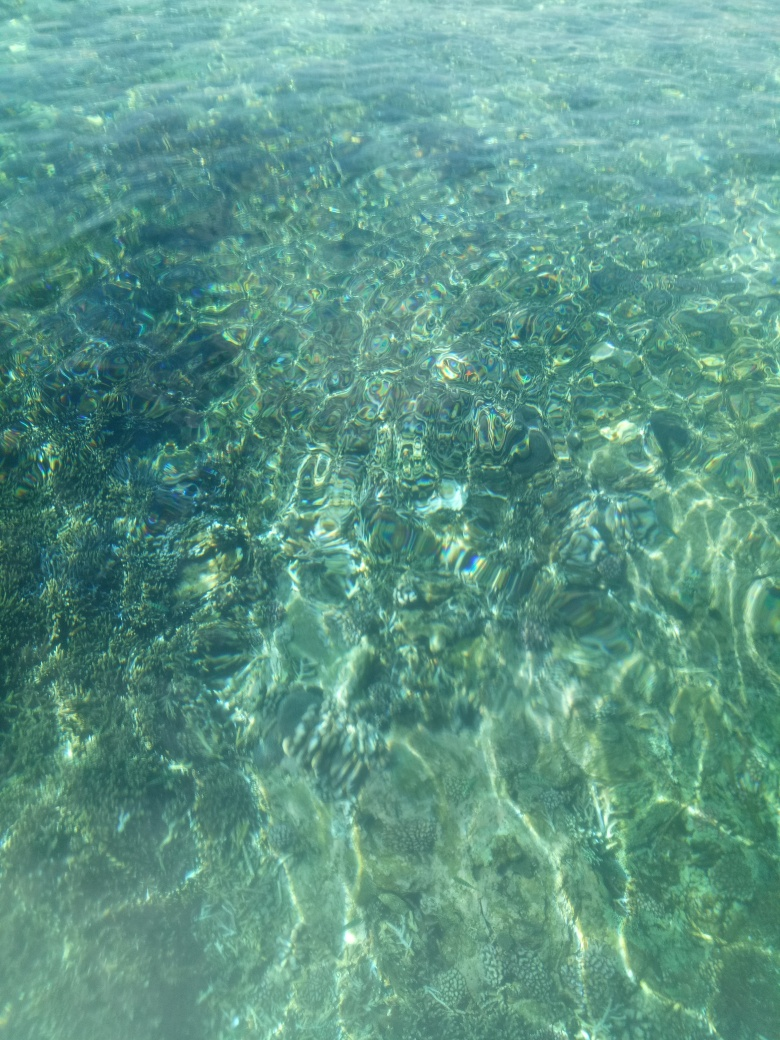Is the image lacking in contrast?
A. Yes
B. No
Answer with the option's letter from the given choices directly.
 B. 